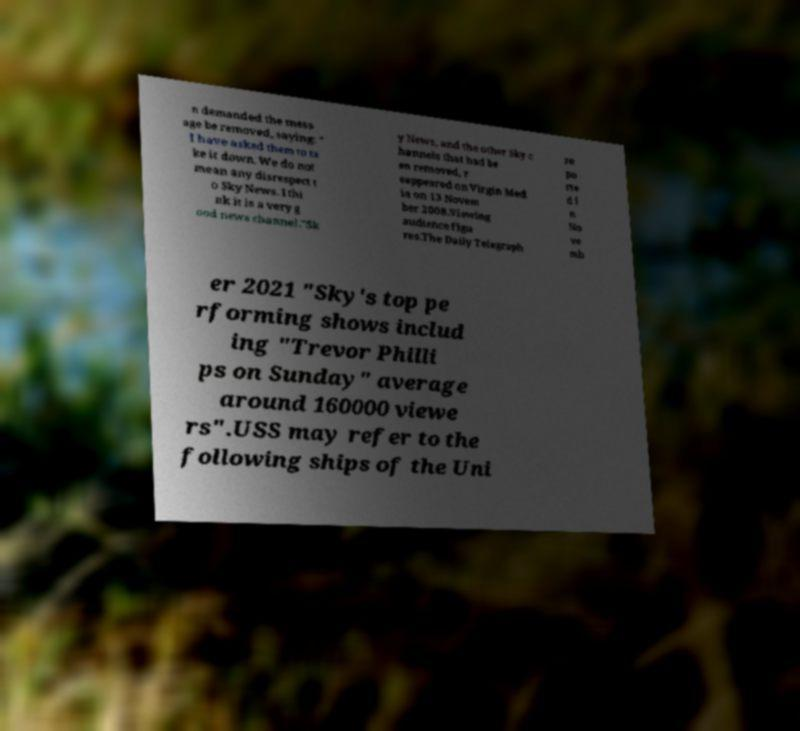Could you assist in decoding the text presented in this image and type it out clearly? n demanded the mess age be removed, saying: " I have asked them to ta ke it down. We do not mean any disrespect t o Sky News. I thi nk it is a very g ood news channel."Sk y News, and the other Sky c hannels that had be en removed, r eappeared on Virgin Med ia on 13 Novem ber 2008.Viewing audience figu res.The Daily Telegraph re po rte d i n No ve mb er 2021 "Sky's top pe rforming shows includ ing "Trevor Philli ps on Sunday" average around 160000 viewe rs".USS may refer to the following ships of the Uni 